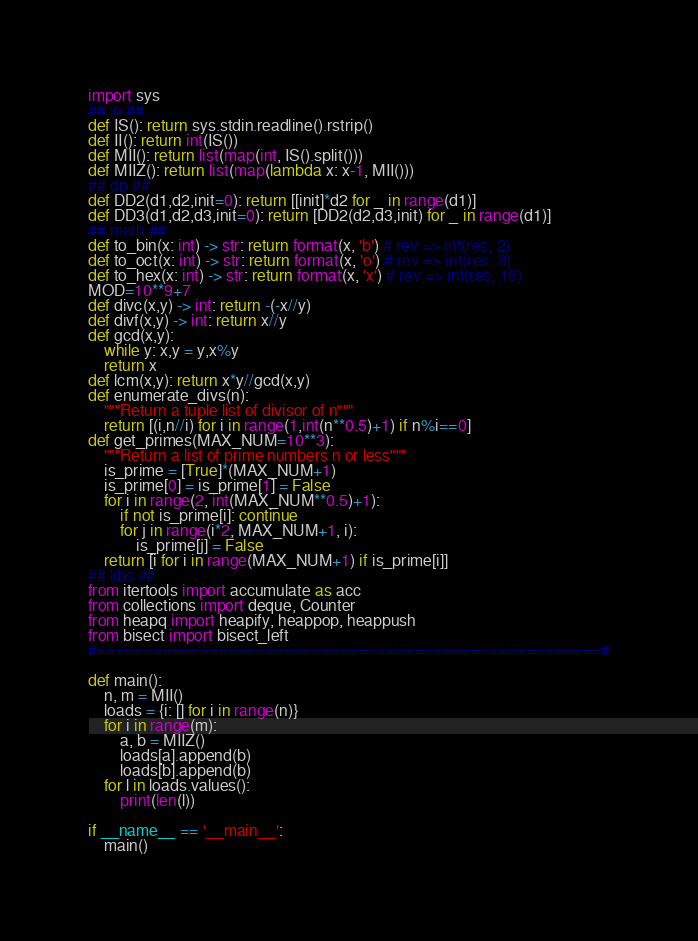Convert code to text. <code><loc_0><loc_0><loc_500><loc_500><_Python_>import sys
## io ##
def IS(): return sys.stdin.readline().rstrip()
def II(): return int(IS())
def MII(): return list(map(int, IS().split()))
def MIIZ(): return list(map(lambda x: x-1, MII()))
## dp ##
def DD2(d1,d2,init=0): return [[init]*d2 for _ in range(d1)]
def DD3(d1,d2,d3,init=0): return [DD2(d2,d3,init) for _ in range(d1)]
## math ##
def to_bin(x: int) -> str: return format(x, 'b') # rev => int(res, 2)
def to_oct(x: int) -> str: return format(x, 'o') # rev => int(res, 8)
def to_hex(x: int) -> str: return format(x, 'x') # rev => int(res, 16)
MOD=10**9+7
def divc(x,y) -> int: return -(-x//y)
def divf(x,y) -> int: return x//y
def gcd(x,y):
    while y: x,y = y,x%y
    return x
def lcm(x,y): return x*y//gcd(x,y)
def enumerate_divs(n):
    """Return a tuple list of divisor of n"""
    return [(i,n//i) for i in range(1,int(n**0.5)+1) if n%i==0]
def get_primes(MAX_NUM=10**3):
    """Return a list of prime numbers n or less"""
    is_prime = [True]*(MAX_NUM+1)
    is_prime[0] = is_prime[1] = False
    for i in range(2, int(MAX_NUM**0.5)+1):
        if not is_prime[i]: continue
        for j in range(i*2, MAX_NUM+1, i):
            is_prime[j] = False
    return [i for i in range(MAX_NUM+1) if is_prime[i]]
## libs ##
from itertools import accumulate as acc
from collections import deque, Counter
from heapq import heapify, heappop, heappush
from bisect import bisect_left
#======================================================#

def main():
    n, m = MII()
    loads = {i: [] for i in range(n)}
    for i in range(m):
        a, b = MIIZ()
        loads[a].append(b)
        loads[b].append(b)
    for l in loads.values():
        print(len(l))

if __name__ == '__main__':
    main()</code> 